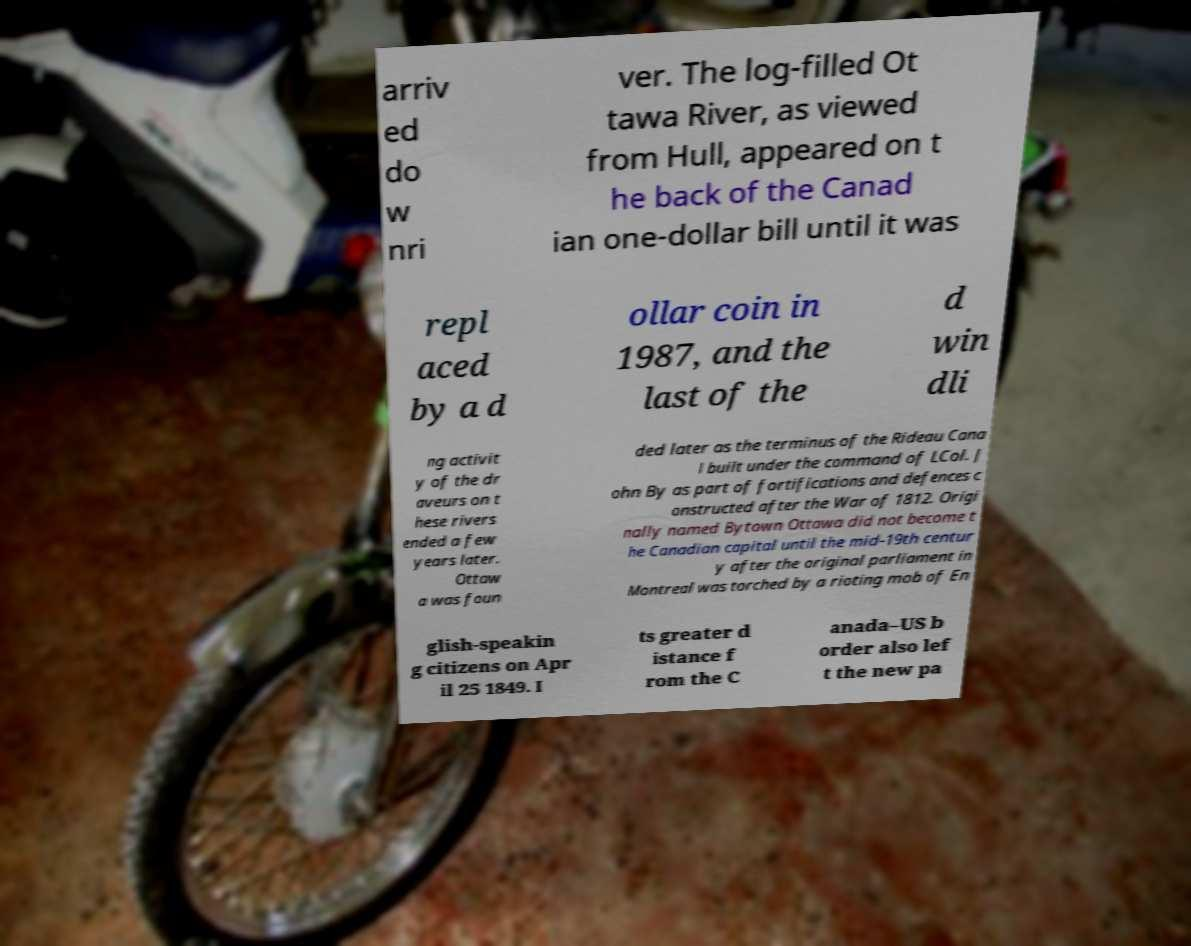Can you read and provide the text displayed in the image?This photo seems to have some interesting text. Can you extract and type it out for me? arriv ed do w nri ver. The log-filled Ot tawa River, as viewed from Hull, appeared on t he back of the Canad ian one-dollar bill until it was repl aced by a d ollar coin in 1987, and the last of the d win dli ng activit y of the dr aveurs on t hese rivers ended a few years later. Ottaw a was foun ded later as the terminus of the Rideau Cana l built under the command of LCol. J ohn By as part of fortifications and defences c onstructed after the War of 1812. Origi nally named Bytown Ottawa did not become t he Canadian capital until the mid-19th centur y after the original parliament in Montreal was torched by a rioting mob of En glish-speakin g citizens on Apr il 25 1849. I ts greater d istance f rom the C anada–US b order also lef t the new pa 